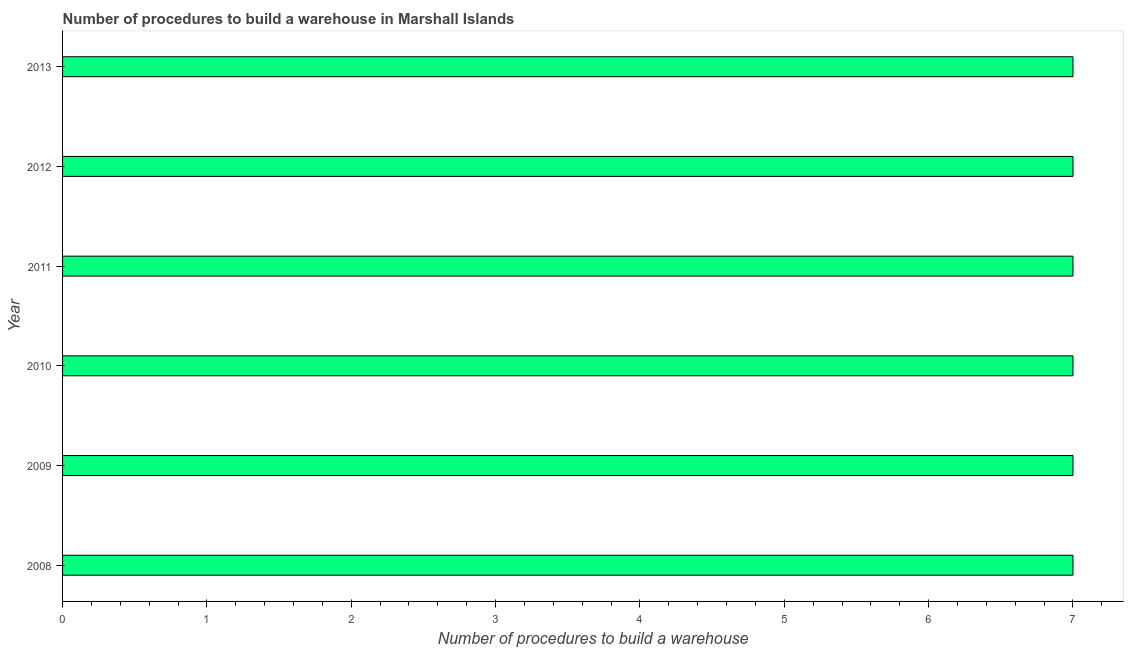What is the title of the graph?
Ensure brevity in your answer.  Number of procedures to build a warehouse in Marshall Islands. What is the label or title of the X-axis?
Give a very brief answer. Number of procedures to build a warehouse. What is the label or title of the Y-axis?
Offer a very short reply. Year. Across all years, what is the maximum number of procedures to build a warehouse?
Give a very brief answer. 7. Across all years, what is the minimum number of procedures to build a warehouse?
Offer a very short reply. 7. In which year was the number of procedures to build a warehouse maximum?
Offer a very short reply. 2008. In which year was the number of procedures to build a warehouse minimum?
Ensure brevity in your answer.  2008. What is the sum of the number of procedures to build a warehouse?
Keep it short and to the point. 42. What is the average number of procedures to build a warehouse per year?
Ensure brevity in your answer.  7. What is the ratio of the number of procedures to build a warehouse in 2009 to that in 2010?
Ensure brevity in your answer.  1. Is the difference between the number of procedures to build a warehouse in 2009 and 2011 greater than the difference between any two years?
Your answer should be very brief. Yes. Is the sum of the number of procedures to build a warehouse in 2008 and 2009 greater than the maximum number of procedures to build a warehouse across all years?
Make the answer very short. Yes. What is the difference between the highest and the lowest number of procedures to build a warehouse?
Provide a succinct answer. 0. What is the difference between two consecutive major ticks on the X-axis?
Offer a terse response. 1. Are the values on the major ticks of X-axis written in scientific E-notation?
Your answer should be very brief. No. What is the Number of procedures to build a warehouse in 2008?
Offer a terse response. 7. What is the Number of procedures to build a warehouse of 2009?
Offer a very short reply. 7. What is the Number of procedures to build a warehouse of 2010?
Your answer should be very brief. 7. What is the Number of procedures to build a warehouse in 2011?
Your answer should be compact. 7. What is the difference between the Number of procedures to build a warehouse in 2008 and 2010?
Offer a very short reply. 0. What is the difference between the Number of procedures to build a warehouse in 2008 and 2011?
Keep it short and to the point. 0. What is the difference between the Number of procedures to build a warehouse in 2008 and 2012?
Offer a terse response. 0. What is the difference between the Number of procedures to build a warehouse in 2008 and 2013?
Make the answer very short. 0. What is the difference between the Number of procedures to build a warehouse in 2009 and 2010?
Give a very brief answer. 0. What is the difference between the Number of procedures to build a warehouse in 2009 and 2011?
Your answer should be compact. 0. What is the difference between the Number of procedures to build a warehouse in 2010 and 2011?
Offer a very short reply. 0. What is the difference between the Number of procedures to build a warehouse in 2010 and 2013?
Give a very brief answer. 0. What is the difference between the Number of procedures to build a warehouse in 2011 and 2012?
Your answer should be very brief. 0. What is the difference between the Number of procedures to build a warehouse in 2012 and 2013?
Your response must be concise. 0. What is the ratio of the Number of procedures to build a warehouse in 2008 to that in 2010?
Provide a succinct answer. 1. What is the ratio of the Number of procedures to build a warehouse in 2008 to that in 2011?
Ensure brevity in your answer.  1. What is the ratio of the Number of procedures to build a warehouse in 2008 to that in 2013?
Your response must be concise. 1. What is the ratio of the Number of procedures to build a warehouse in 2009 to that in 2013?
Give a very brief answer. 1. What is the ratio of the Number of procedures to build a warehouse in 2010 to that in 2011?
Ensure brevity in your answer.  1. What is the ratio of the Number of procedures to build a warehouse in 2011 to that in 2013?
Provide a short and direct response. 1. What is the ratio of the Number of procedures to build a warehouse in 2012 to that in 2013?
Keep it short and to the point. 1. 